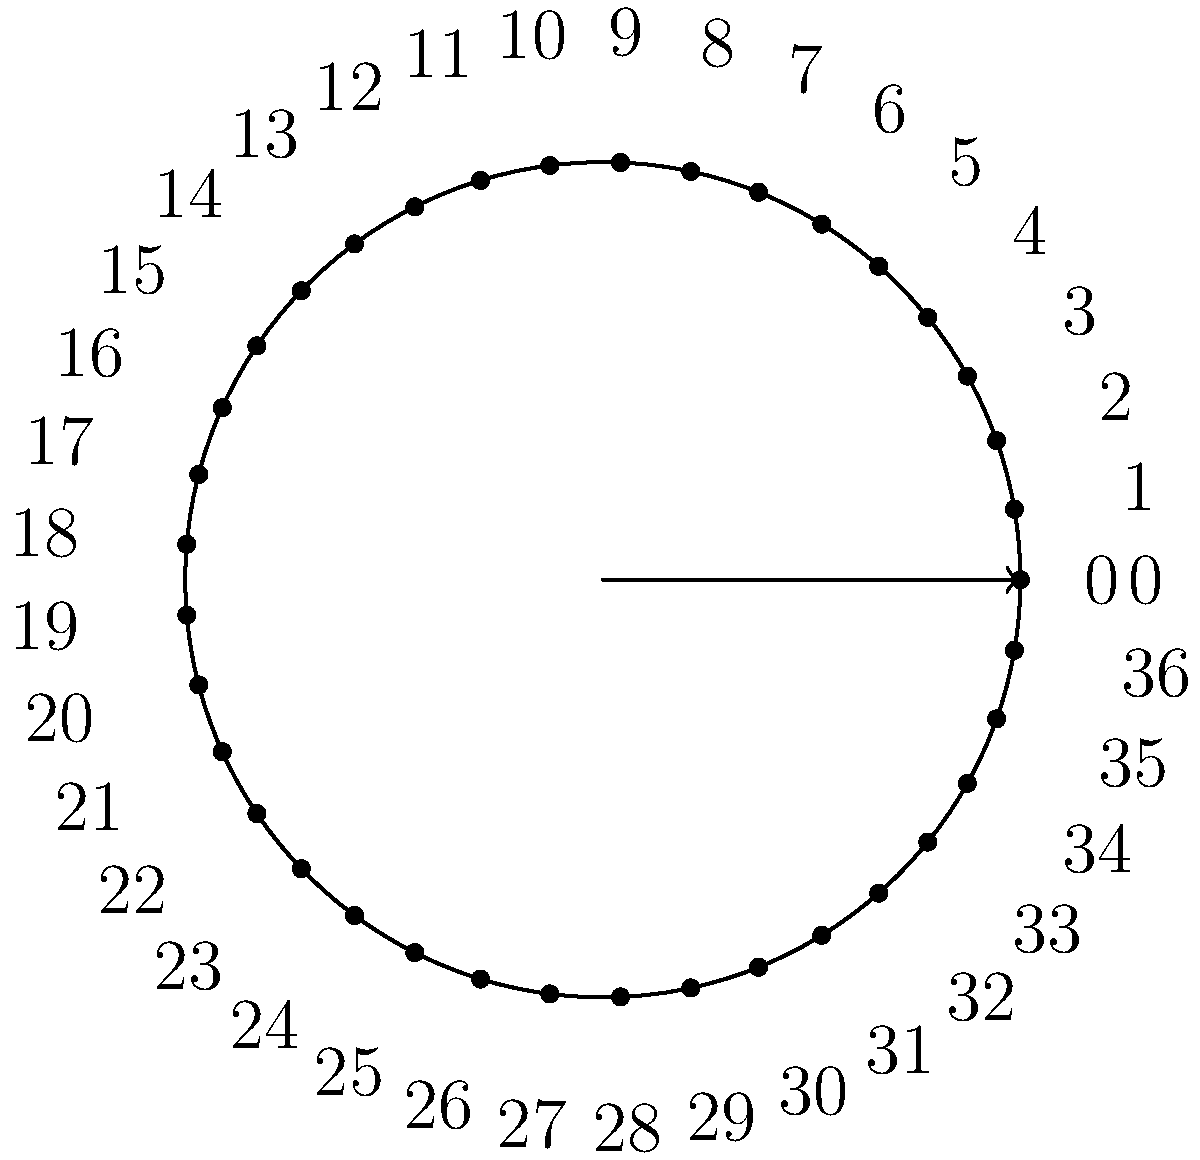Consider a standard European roulette wheel with 37 numbered pockets (0 to 36). What is the order of the symmetry group for this roulette wheel, considering rotations that align the numbers? To determine the order of the symmetry group for the roulette wheel, we need to follow these steps:

1) First, recall that the order of a symmetry group is the number of unique symmetry operations that can be performed on the object.

2) For a roulette wheel, the relevant symmetry operations are rotations that align the numbers.

3) The European roulette wheel has 37 numbered pockets (0 to 36).

4) Any rotation that moves the wheel by a multiple of $\frac{360°}{37}$ will result in a valid alignment of the numbers.

5) Therefore, there are 37 possible rotations (including the identity rotation of 0°) that will result in a valid alignment:
   
   $0°, \frac{360°}{37}, \frac{720°}{37}, ..., \frac{36 \times 360°}{37}$

6) Each of these rotations corresponds to a unique element in the symmetry group.

7) Thus, the order of the symmetry group is 37.

This group is isomorphic to the cyclic group $C_{37}$, which makes sense given the circular nature of the roulette wheel.
Answer: 37 